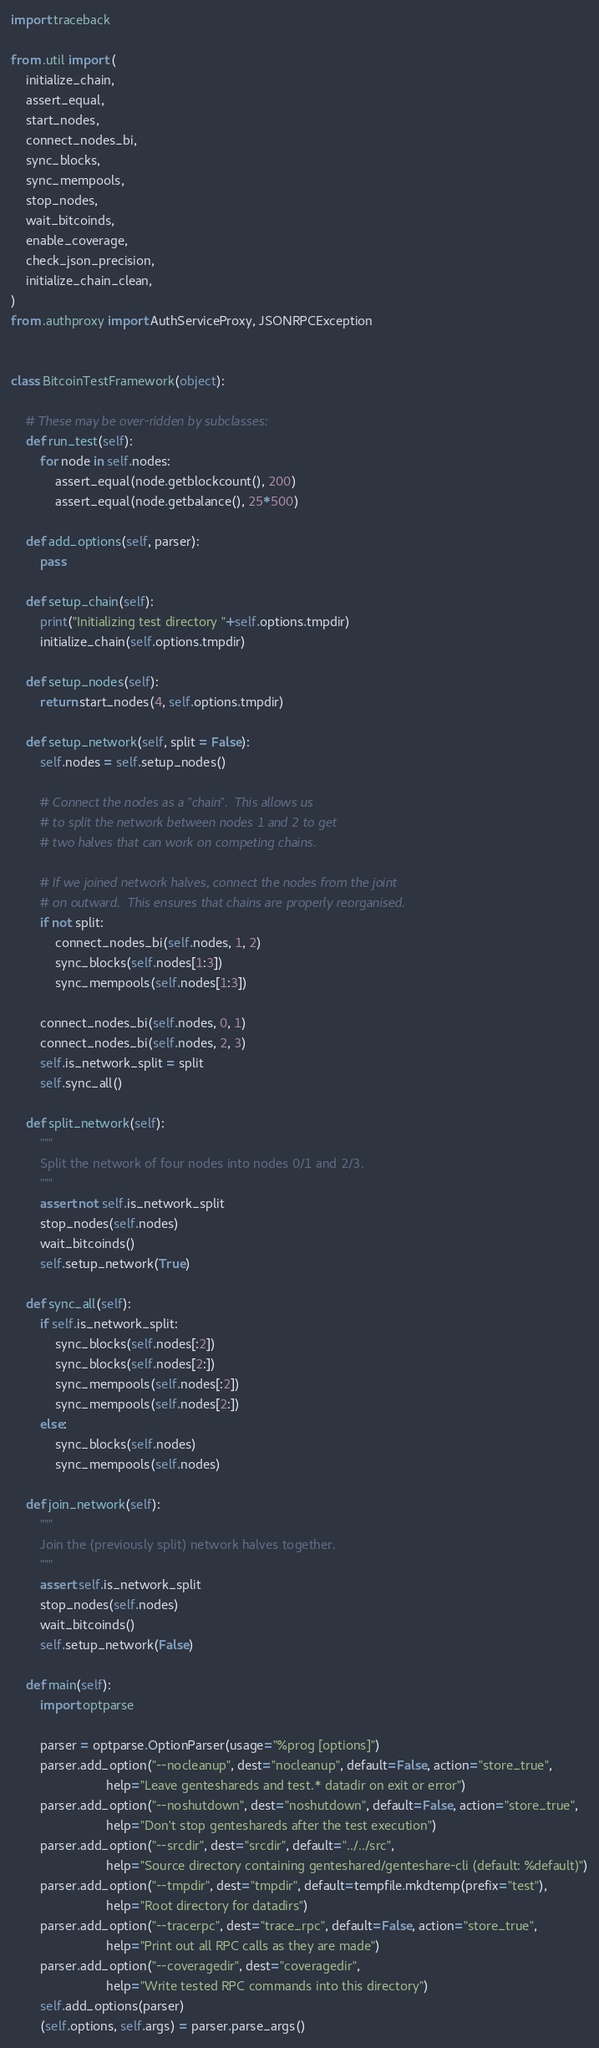Convert code to text. <code><loc_0><loc_0><loc_500><loc_500><_Python_>import traceback

from .util import (
    initialize_chain,
    assert_equal,
    start_nodes,
    connect_nodes_bi,
    sync_blocks,
    sync_mempools,
    stop_nodes,
    wait_bitcoinds,
    enable_coverage,
    check_json_precision,
    initialize_chain_clean,
)
from .authproxy import AuthServiceProxy, JSONRPCException


class BitcoinTestFramework(object):

    # These may be over-ridden by subclasses:
    def run_test(self):
        for node in self.nodes:
            assert_equal(node.getblockcount(), 200)
            assert_equal(node.getbalance(), 25*500)

    def add_options(self, parser):
        pass

    def setup_chain(self):
        print("Initializing test directory "+self.options.tmpdir)
        initialize_chain(self.options.tmpdir)

    def setup_nodes(self):
        return start_nodes(4, self.options.tmpdir)

    def setup_network(self, split = False):
        self.nodes = self.setup_nodes()

        # Connect the nodes as a "chain".  This allows us
        # to split the network between nodes 1 and 2 to get
        # two halves that can work on competing chains.

        # If we joined network halves, connect the nodes from the joint
        # on outward.  This ensures that chains are properly reorganised.
        if not split:
            connect_nodes_bi(self.nodes, 1, 2)
            sync_blocks(self.nodes[1:3])
            sync_mempools(self.nodes[1:3])

        connect_nodes_bi(self.nodes, 0, 1)
        connect_nodes_bi(self.nodes, 2, 3)
        self.is_network_split = split
        self.sync_all()

    def split_network(self):
        """
        Split the network of four nodes into nodes 0/1 and 2/3.
        """
        assert not self.is_network_split
        stop_nodes(self.nodes)
        wait_bitcoinds()
        self.setup_network(True)

    def sync_all(self):
        if self.is_network_split:
            sync_blocks(self.nodes[:2])
            sync_blocks(self.nodes[2:])
            sync_mempools(self.nodes[:2])
            sync_mempools(self.nodes[2:])
        else:
            sync_blocks(self.nodes)
            sync_mempools(self.nodes)

    def join_network(self):
        """
        Join the (previously split) network halves together.
        """
        assert self.is_network_split
        stop_nodes(self.nodes)
        wait_bitcoinds()
        self.setup_network(False)

    def main(self):
        import optparse

        parser = optparse.OptionParser(usage="%prog [options]")
        parser.add_option("--nocleanup", dest="nocleanup", default=False, action="store_true",
                          help="Leave genteshareds and test.* datadir on exit or error")
        parser.add_option("--noshutdown", dest="noshutdown", default=False, action="store_true",
                          help="Don't stop genteshareds after the test execution")
        parser.add_option("--srcdir", dest="srcdir", default="../../src",
                          help="Source directory containing genteshared/genteshare-cli (default: %default)")
        parser.add_option("--tmpdir", dest="tmpdir", default=tempfile.mkdtemp(prefix="test"),
                          help="Root directory for datadirs")
        parser.add_option("--tracerpc", dest="trace_rpc", default=False, action="store_true",
                          help="Print out all RPC calls as they are made")
        parser.add_option("--coveragedir", dest="coveragedir",
                          help="Write tested RPC commands into this directory")
        self.add_options(parser)
        (self.options, self.args) = parser.parse_args()
</code> 